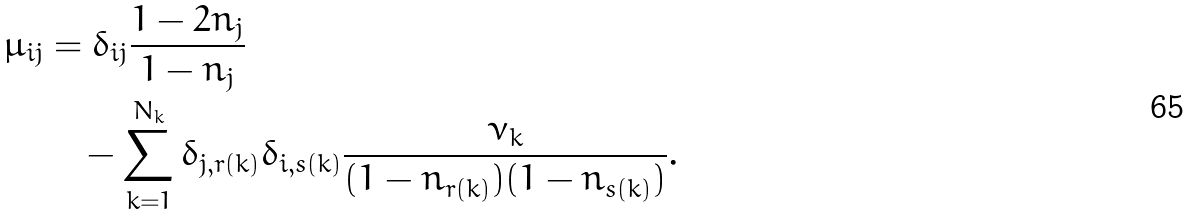Convert formula to latex. <formula><loc_0><loc_0><loc_500><loc_500>\mu _ { i j } & = \delta _ { i j } \frac { 1 - 2 n _ { j } } { 1 - n _ { j } } \\ & \quad - \sum _ { k = 1 } ^ { N _ { k } } \delta _ { j , r ( k ) } \delta _ { i , s ( k ) } \frac { \nu _ { k } } { ( 1 - n _ { r ( k ) } ) ( 1 - n _ { s ( k ) } ) } .</formula> 